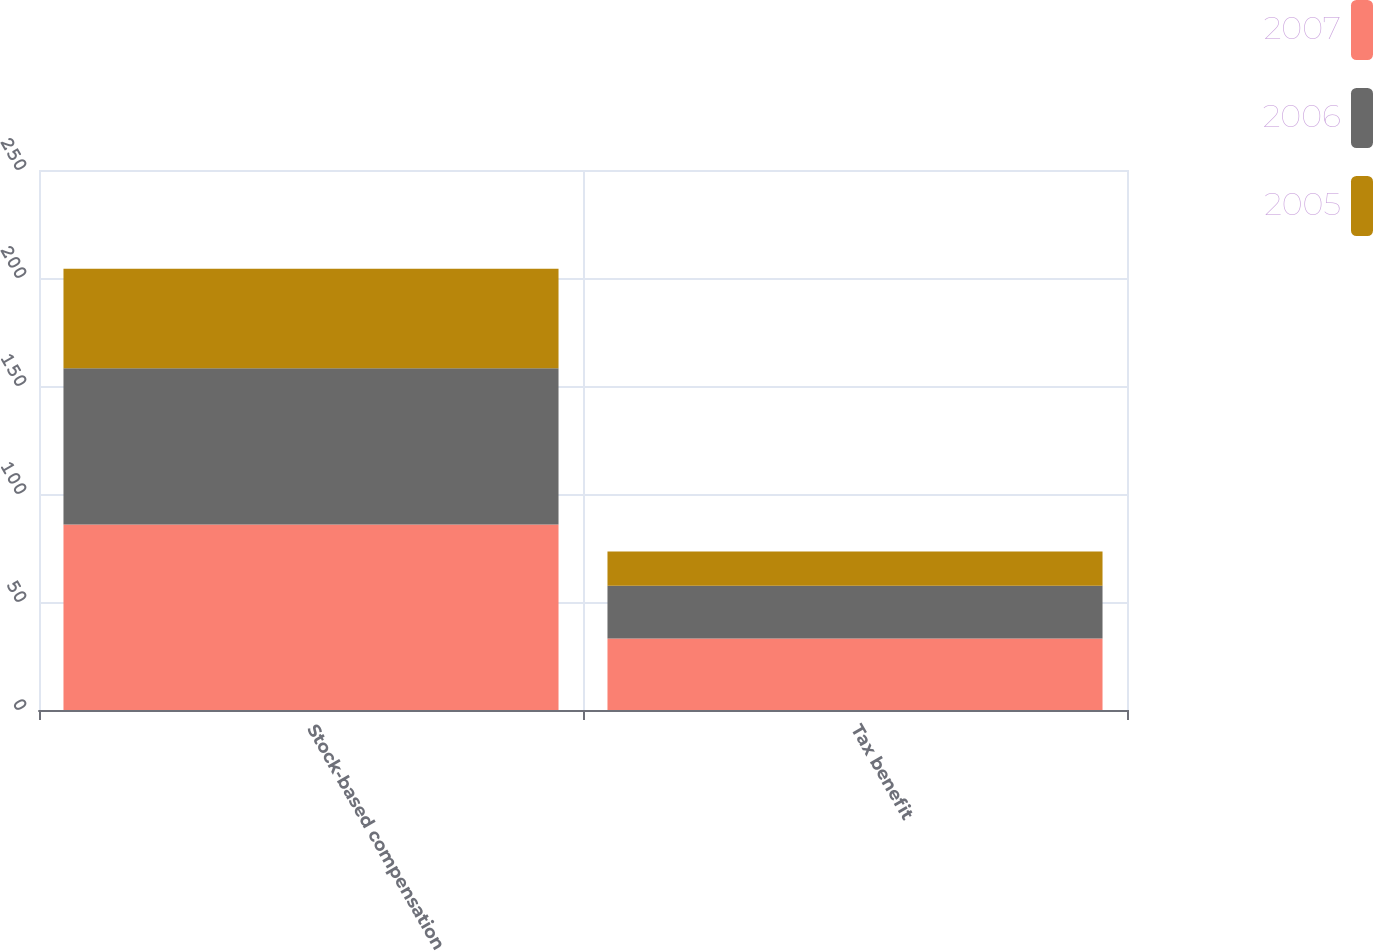Convert chart. <chart><loc_0><loc_0><loc_500><loc_500><stacked_bar_chart><ecel><fcel>Stock-based compensation<fcel>Tax benefit<nl><fcel>2007<fcel>85.9<fcel>33.1<nl><fcel>2006<fcel>72.3<fcel>24.4<nl><fcel>2005<fcel>46.1<fcel>15.9<nl></chart> 